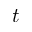Convert formula to latex. <formula><loc_0><loc_0><loc_500><loc_500>t</formula> 